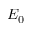Convert formula to latex. <formula><loc_0><loc_0><loc_500><loc_500>E _ { 0 }</formula> 